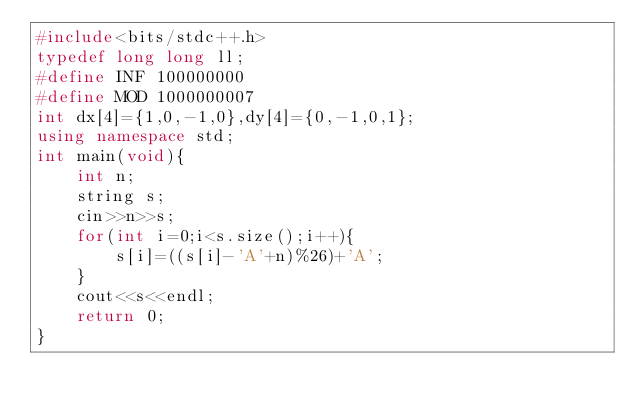Convert code to text. <code><loc_0><loc_0><loc_500><loc_500><_C++_>#include<bits/stdc++.h>
typedef long long ll;
#define INF 100000000
#define MOD 1000000007
int dx[4]={1,0,-1,0},dy[4]={0,-1,0,1};
using namespace std;
int main(void){
    int n;
    string s;
    cin>>n>>s;
    for(int i=0;i<s.size();i++){
        s[i]=((s[i]-'A'+n)%26)+'A';
    }
    cout<<s<<endl;
    return 0;
}</code> 